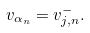Convert formula to latex. <formula><loc_0><loc_0><loc_500><loc_500>v _ { \alpha _ { n } } = v _ { j , n } ^ { - } .</formula> 